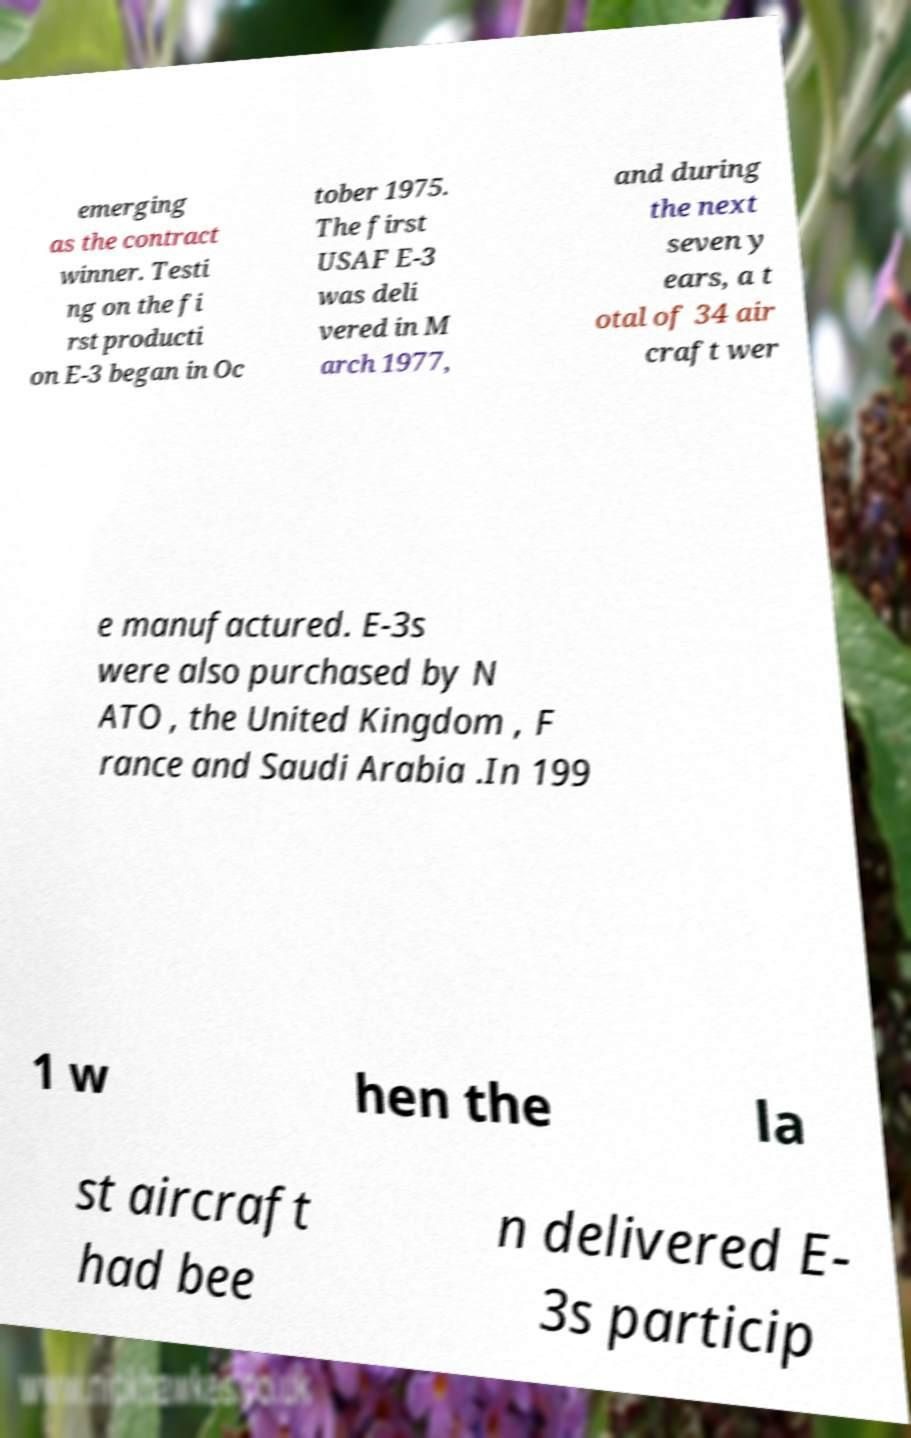Can you read and provide the text displayed in the image?This photo seems to have some interesting text. Can you extract and type it out for me? emerging as the contract winner. Testi ng on the fi rst producti on E-3 began in Oc tober 1975. The first USAF E-3 was deli vered in M arch 1977, and during the next seven y ears, a t otal of 34 air craft wer e manufactured. E-3s were also purchased by N ATO , the United Kingdom , F rance and Saudi Arabia .In 199 1 w hen the la st aircraft had bee n delivered E- 3s particip 